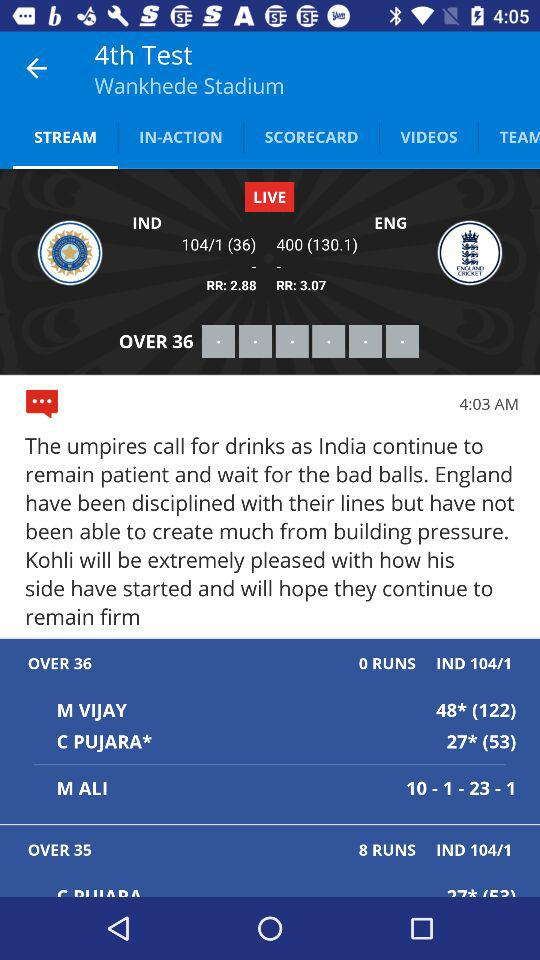Which tab am I on? You are on "STREAM" tab. 